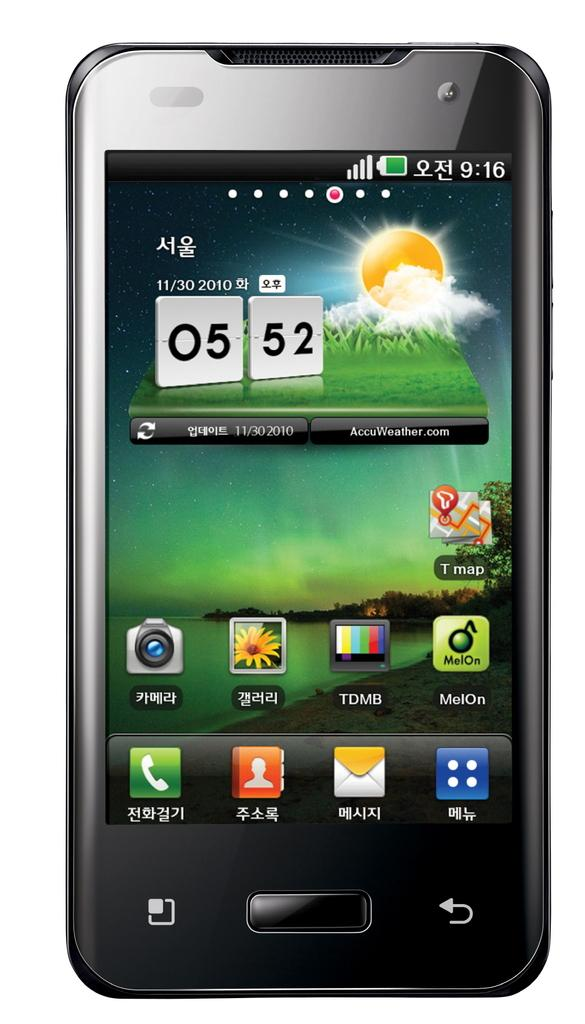<image>
Offer a succinct explanation of the picture presented. a cell phone display with an icons for T Map and MelOn 